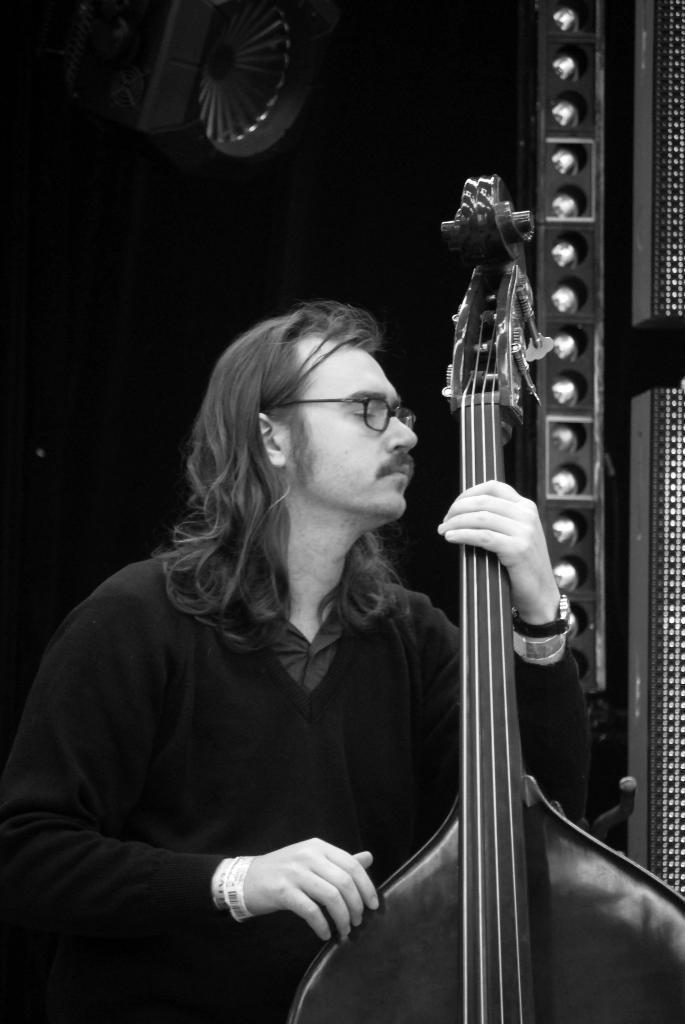Describe this image in one or two sentences. In this image we can see a man holding a musical instrument. In the background there is a wall. 